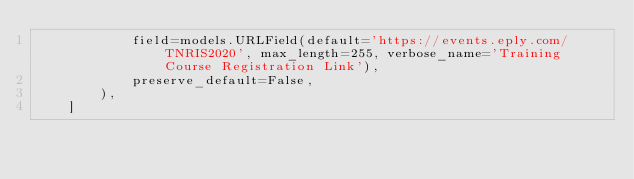Convert code to text. <code><loc_0><loc_0><loc_500><loc_500><_Python_>            field=models.URLField(default='https://events.eply.com/TNRIS2020', max_length=255, verbose_name='Training Course Registration Link'),
            preserve_default=False,
        ),
    ]
</code> 